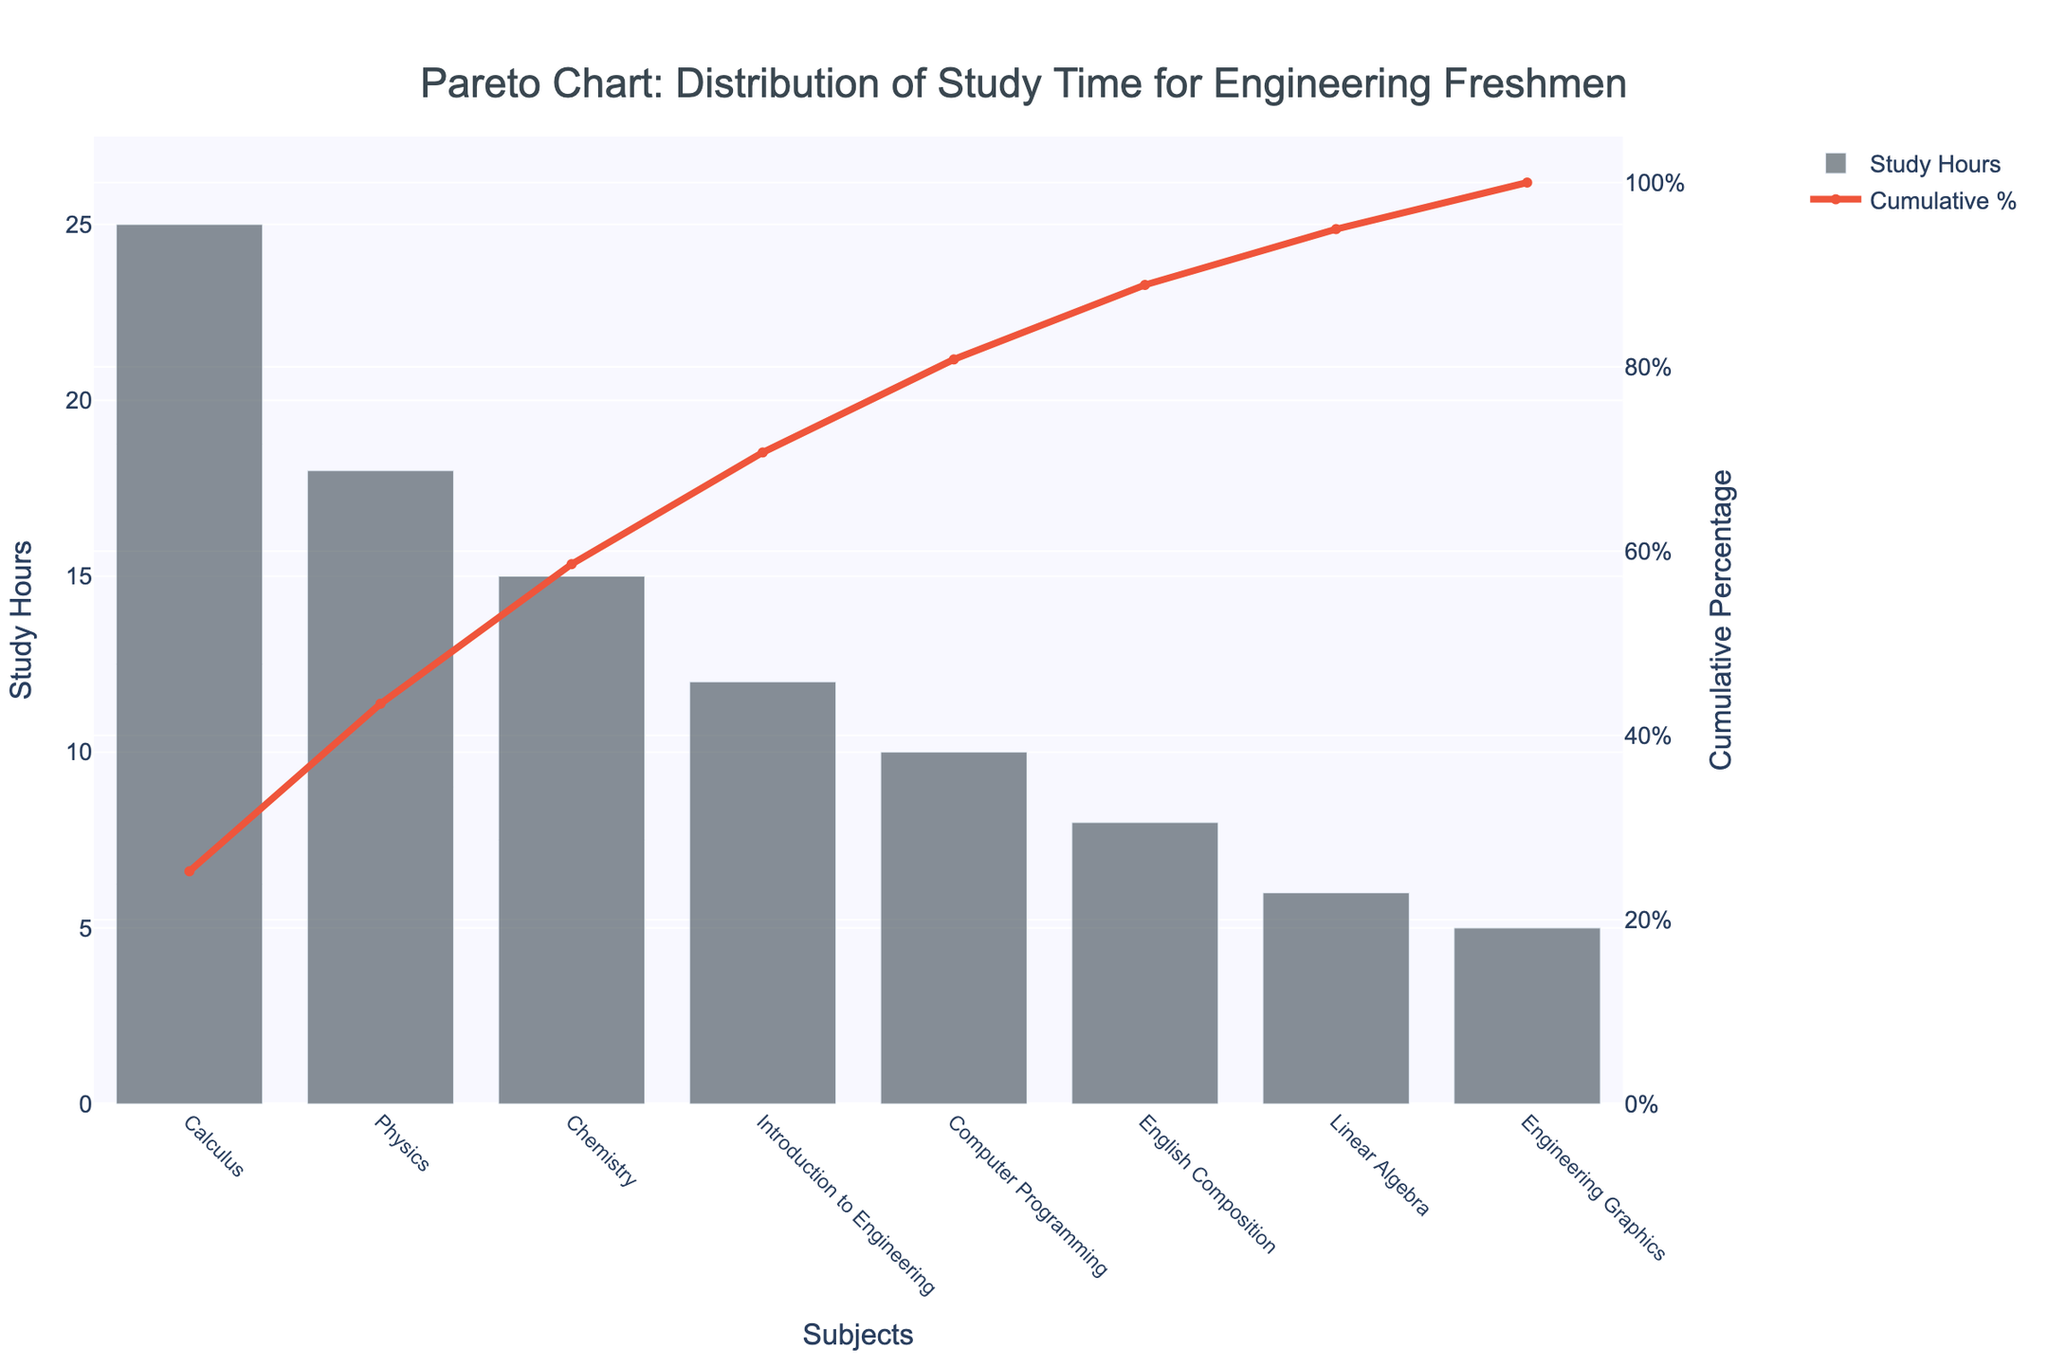What's the title of the figure? The title is located at the top of the figure and it is usually in a larger font size to easily identify it. It reads: "Pareto Chart: Distribution of Study Time for Engineering Freshmen".
Answer: Pareto Chart: Distribution of Study Time for Engineering Freshmen How many subjects are included in the chart? The x-axis of the chart lists each subject included in the study. Count the number of distinct subjects listed. There are 8 subjects: Calculus, Physics, Chemistry, Introduction to Engineering, Computer Programming, English Composition, Linear Algebra, and Engineering Graphics.
Answer: 8 Which subject has the highest study hours? Look at the height of the bars in the bar chart, which correspond to study hours for each subject. The tallest bar represents the highest study hours. It shows Calculus with 25 hours.
Answer: Calculus What is the cumulative percentage after studying Calculus and Physics? Locate the subjects Calculus and Physics and refer to their corresponding cumulative percentage values. For Calculus, it's the first point on the cumulative percentage line and for Physics, it's the second point. Calculus is 25/(25+18+15+12+10+8+6+5)*100 = 25/99*100 ≈ 25.25%. Physics cumulatively is (25+18)/(25+18+15+12+10+8+6+5)*100 = 43/99*100 ≈ 43.43%
Answer: 43.43% Which subject's bar is closest in height to English Composition's bar? Find English Composition's bar and compare its height to those of the other subjects. English Composition has 8 hours. The subject whose bar is closest in height is Linear Algebra with 6 hours.
Answer: Linear Algebra What is the approximate cumulative percentage after studying the first four subjects with the highest study hours? Add up the study hours for the first four subjects (Calculus, Physics, Chemistry, and Introduction to Engineering) and then divide by the total hours and multiply by 100. (25+18+15+12)/(25+18+15+12+10+8+6+5)*100 = 70/99*100 ≈ 70.71%
Answer: 70.71% How does the study time for Introduction to Engineering compare to Engineering Graphics? Check the heights of the bars for Introduction to Engineering and Engineering Graphics. Introduction to Engineering has 12 hours, while Engineering Graphics has 5 hours. Introduction to Engineering has more study hours than Engineering Graphics.
Answer: Introduction to Engineering has more hours What are the subjects and study hours for those contributing to the highest 50% cumulative percentage? Identify the subjects from the cumulative percentage line where the percentage reaches or exceeds 50%. By the subject Chemistry, the cumulative percentage is 43.43% (from Physics) + 15.15% (from Chemistry) = 58.58%. So, the subjects are Calculus (25), Physics (18), Chemistry (15).
Answer: Calculus - 25, Physics - 18, Chemistry - 15 What is the color of the cumulative percentage line? Observe the color used for the line in the figure, which represents the cumulative percentage. It's a distinct color from the bar chart and appears to be red.
Answer: Red 